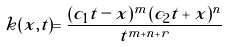Convert formula to latex. <formula><loc_0><loc_0><loc_500><loc_500>k ( x , t ) = \frac { ( c _ { 1 } t - x ) ^ { m } ( c _ { 2 } t + x ) ^ { n } } { t ^ { m + n + r } }</formula> 